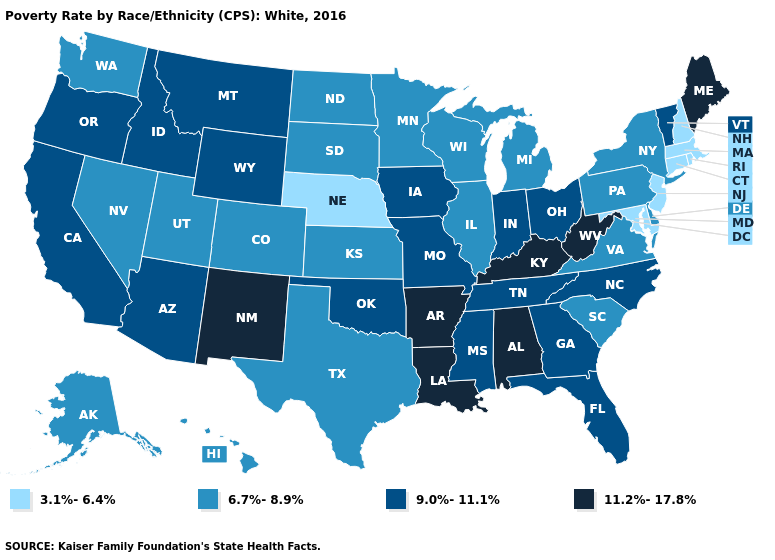What is the highest value in the South ?
Keep it brief. 11.2%-17.8%. What is the value of Utah?
Answer briefly. 6.7%-8.9%. What is the lowest value in states that border North Dakota?
Quick response, please. 6.7%-8.9%. What is the highest value in the MidWest ?
Answer briefly. 9.0%-11.1%. Does Pennsylvania have the same value as Nevada?
Keep it brief. Yes. Name the states that have a value in the range 9.0%-11.1%?
Keep it brief. Arizona, California, Florida, Georgia, Idaho, Indiana, Iowa, Mississippi, Missouri, Montana, North Carolina, Ohio, Oklahoma, Oregon, Tennessee, Vermont, Wyoming. What is the value of Michigan?
Keep it brief. 6.7%-8.9%. Among the states that border New Mexico , which have the highest value?
Give a very brief answer. Arizona, Oklahoma. Which states have the lowest value in the USA?
Be succinct. Connecticut, Maryland, Massachusetts, Nebraska, New Hampshire, New Jersey, Rhode Island. What is the value of New Mexico?
Answer briefly. 11.2%-17.8%. Does the first symbol in the legend represent the smallest category?
Quick response, please. Yes. Name the states that have a value in the range 11.2%-17.8%?
Be succinct. Alabama, Arkansas, Kentucky, Louisiana, Maine, New Mexico, West Virginia. Does Ohio have the lowest value in the MidWest?
Concise answer only. No. What is the value of Michigan?
Write a very short answer. 6.7%-8.9%. What is the value of Nevada?
Write a very short answer. 6.7%-8.9%. 